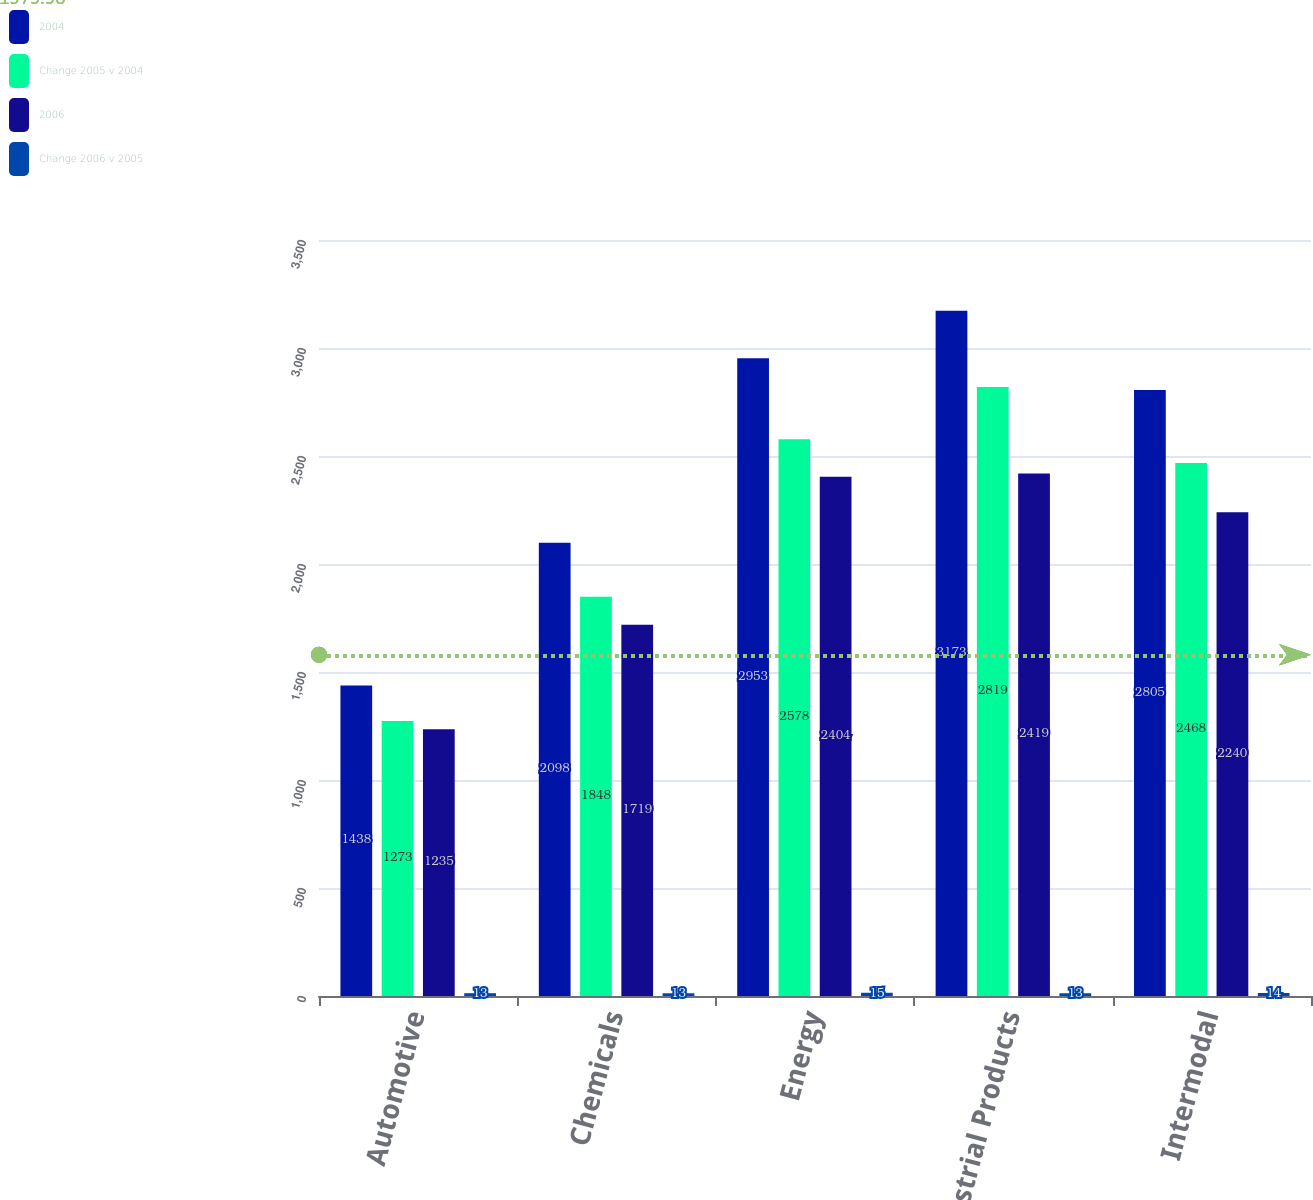<chart> <loc_0><loc_0><loc_500><loc_500><stacked_bar_chart><ecel><fcel>Automotive<fcel>Chemicals<fcel>Energy<fcel>Industrial Products<fcel>Intermodal<nl><fcel>2004<fcel>1438<fcel>2098<fcel>2953<fcel>3173<fcel>2805<nl><fcel>Change 2005 v 2004<fcel>1273<fcel>1848<fcel>2578<fcel>2819<fcel>2468<nl><fcel>2006<fcel>1235<fcel>1719<fcel>2404<fcel>2419<fcel>2240<nl><fcel>Change 2006 v 2005<fcel>13<fcel>13<fcel>15<fcel>13<fcel>14<nl></chart> 